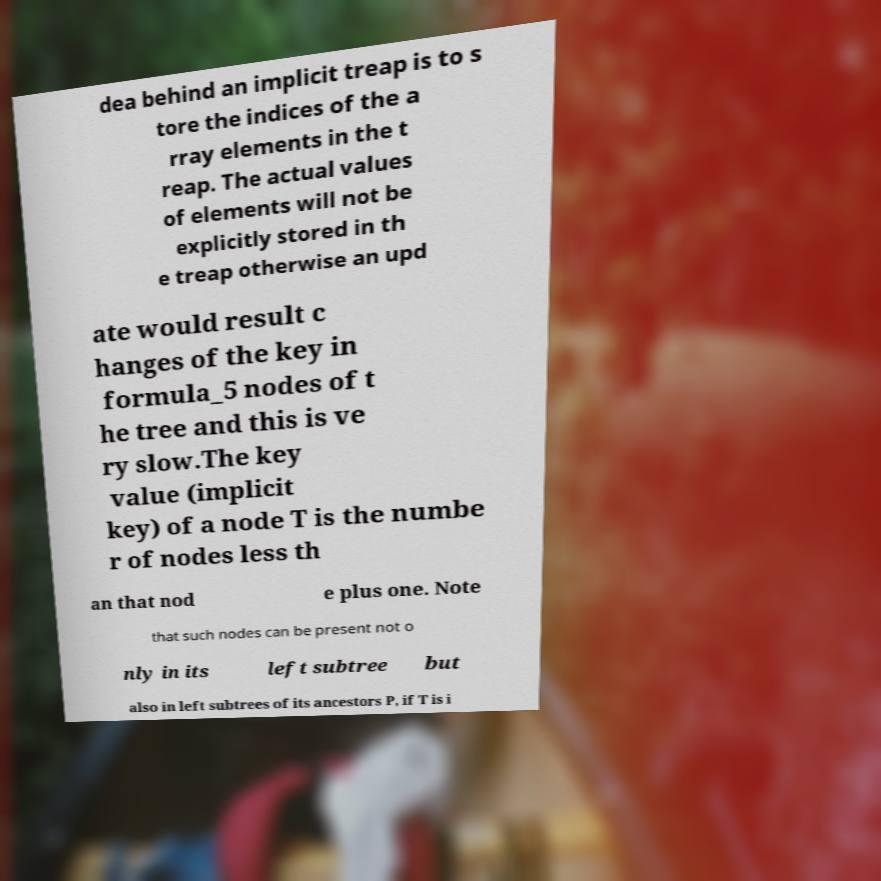Could you extract and type out the text from this image? dea behind an implicit treap is to s tore the indices of the a rray elements in the t reap. The actual values of elements will not be explicitly stored in th e treap otherwise an upd ate would result c hanges of the key in formula_5 nodes of t he tree and this is ve ry slow.The key value (implicit key) of a node T is the numbe r of nodes less th an that nod e plus one. Note that such nodes can be present not o nly in its left subtree but also in left subtrees of its ancestors P, if T is i 